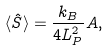<formula> <loc_0><loc_0><loc_500><loc_500>\langle \hat { S } \rangle = \frac { k _ { B } } { 4 L _ { P } ^ { 2 } } A ,</formula> 